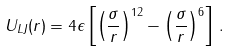<formula> <loc_0><loc_0><loc_500><loc_500>U _ { L J } ( r ) = 4 \epsilon \left [ \left ( \frac { \sigma } { r } \right ) ^ { 1 2 } - \left ( \frac { \sigma } { r } \right ) ^ { 6 } \right ] \, .</formula> 